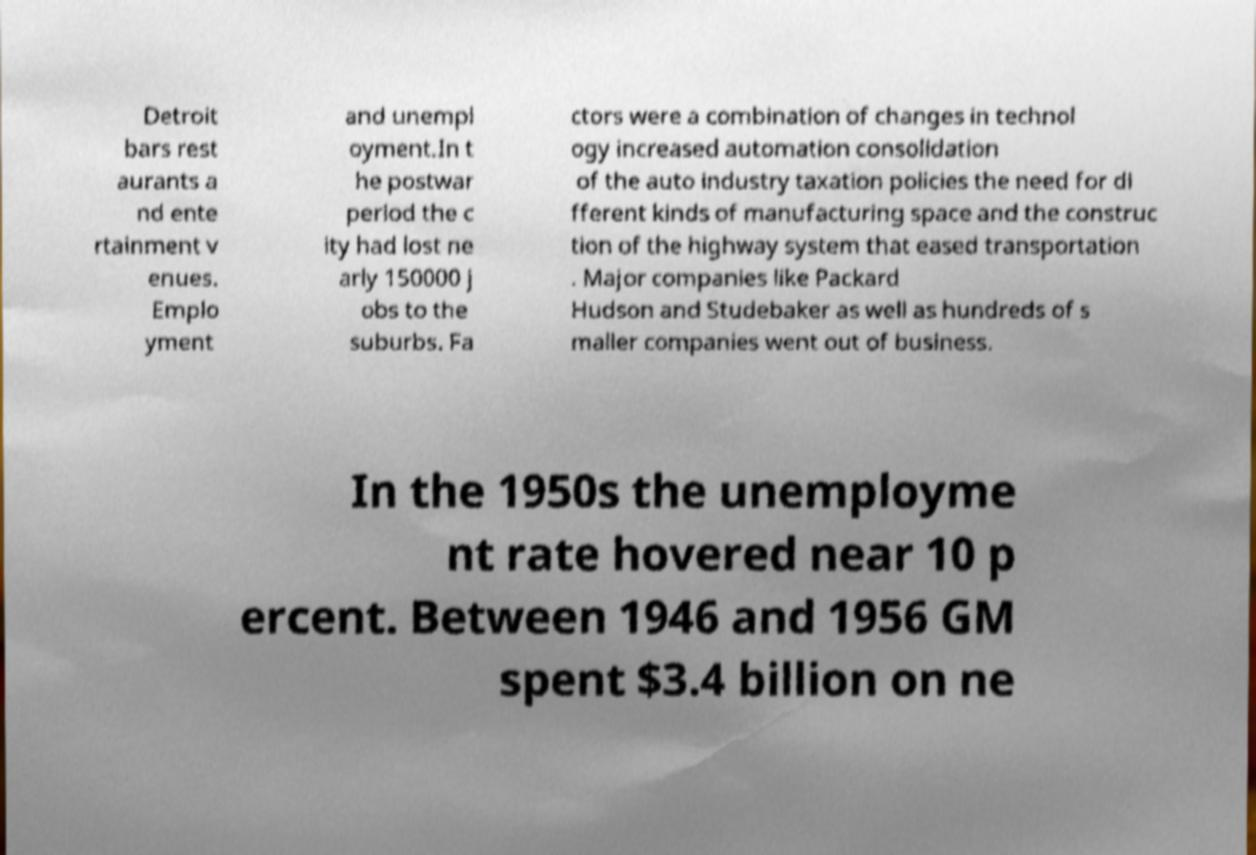Can you read and provide the text displayed in the image?This photo seems to have some interesting text. Can you extract and type it out for me? Detroit bars rest aurants a nd ente rtainment v enues. Emplo yment and unempl oyment.In t he postwar period the c ity had lost ne arly 150000 j obs to the suburbs. Fa ctors were a combination of changes in technol ogy increased automation consolidation of the auto industry taxation policies the need for di fferent kinds of manufacturing space and the construc tion of the highway system that eased transportation . Major companies like Packard Hudson and Studebaker as well as hundreds of s maller companies went out of business. In the 1950s the unemployme nt rate hovered near 10 p ercent. Between 1946 and 1956 GM spent $3.4 billion on ne 